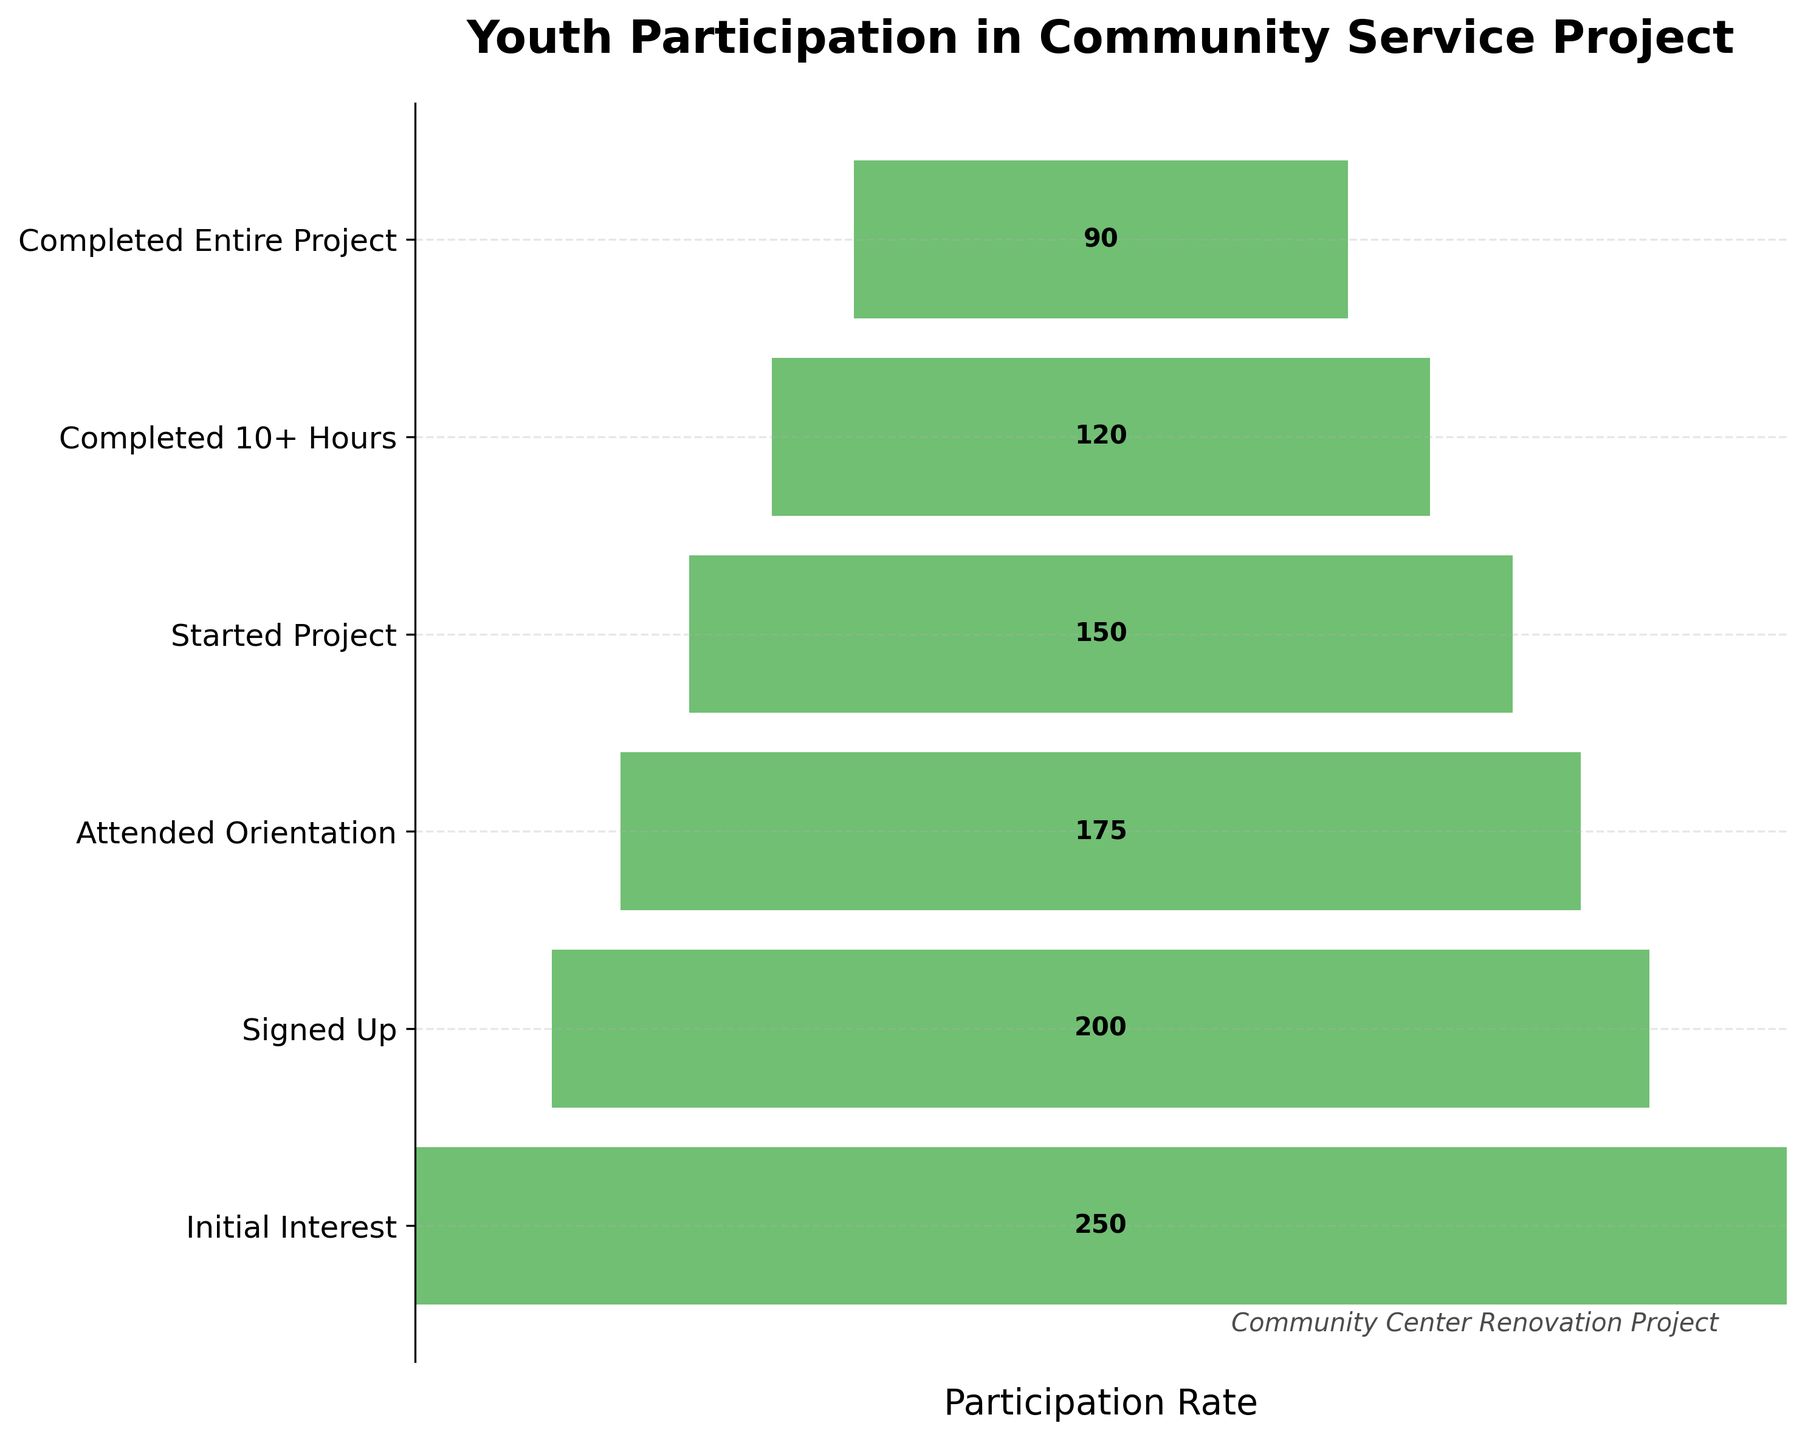What is the title of the chart? The chart's title is prominently displayed at the top and reads "Youth Participation in Community Service Project".
Answer: Youth Participation in Community Service Project How many activities are listed in the chart? By counting the number of horizontal bars or y-axis labels, we can see there are six activities listed on the chart.
Answer: Six How many youths initially showed interest in the project? The number on the bar corresponding to "Initial Interest" shows the count of youths who initially showed interest.
Answer: 250 How many youths completed the entire project? The number on the bar corresponding to "Completed Entire Project" indicates the participants who completed the project.
Answer: 90 By how much did the participation drop from "Signed Up" to "Attended Orientation"? The number of participants for "Signed Up" (200) minus the number of participants for "Attended Orientation" (175) gives the drop in participation.
Answer: 25 What is the participation rate for completing 10+ hours from the initial interest? To find the participation rate, divide the number of participants who completed 10+ hours (120) by the initial number of interested participants (250) and multiply by 100 to get the percentage.
Answer: 48% Which stage saw the largest drop in participation? By comparing the differences between consecutive stages, we can identify the largest drop. The largest drop is from "Initial Interest" (250) to "Signed Up" (200), a drop of 50 participants.
Answer: From Initial Interest to Signed Up What percentage of the youths who started the project completed the entire project? Divide the number of participants who completed the entire project (90) by the number of participants who started the project (150) and multiply by 100 to get the percentage.
Answer: 60% How many more participants were there in the "Started Project" stage compared to the "Completed 10+ Hours" stage? Subtract the number of participants who completed 10+ hours (120) from those who started the project (150) to find the difference.
Answer: 30 What is the ratio of youths who attended orientation to those who signed up? The ratio can be found by dividing the number who attended orientation (175) by those who signed up (200). This simplifies to 7:8.
Answer: 7:8 